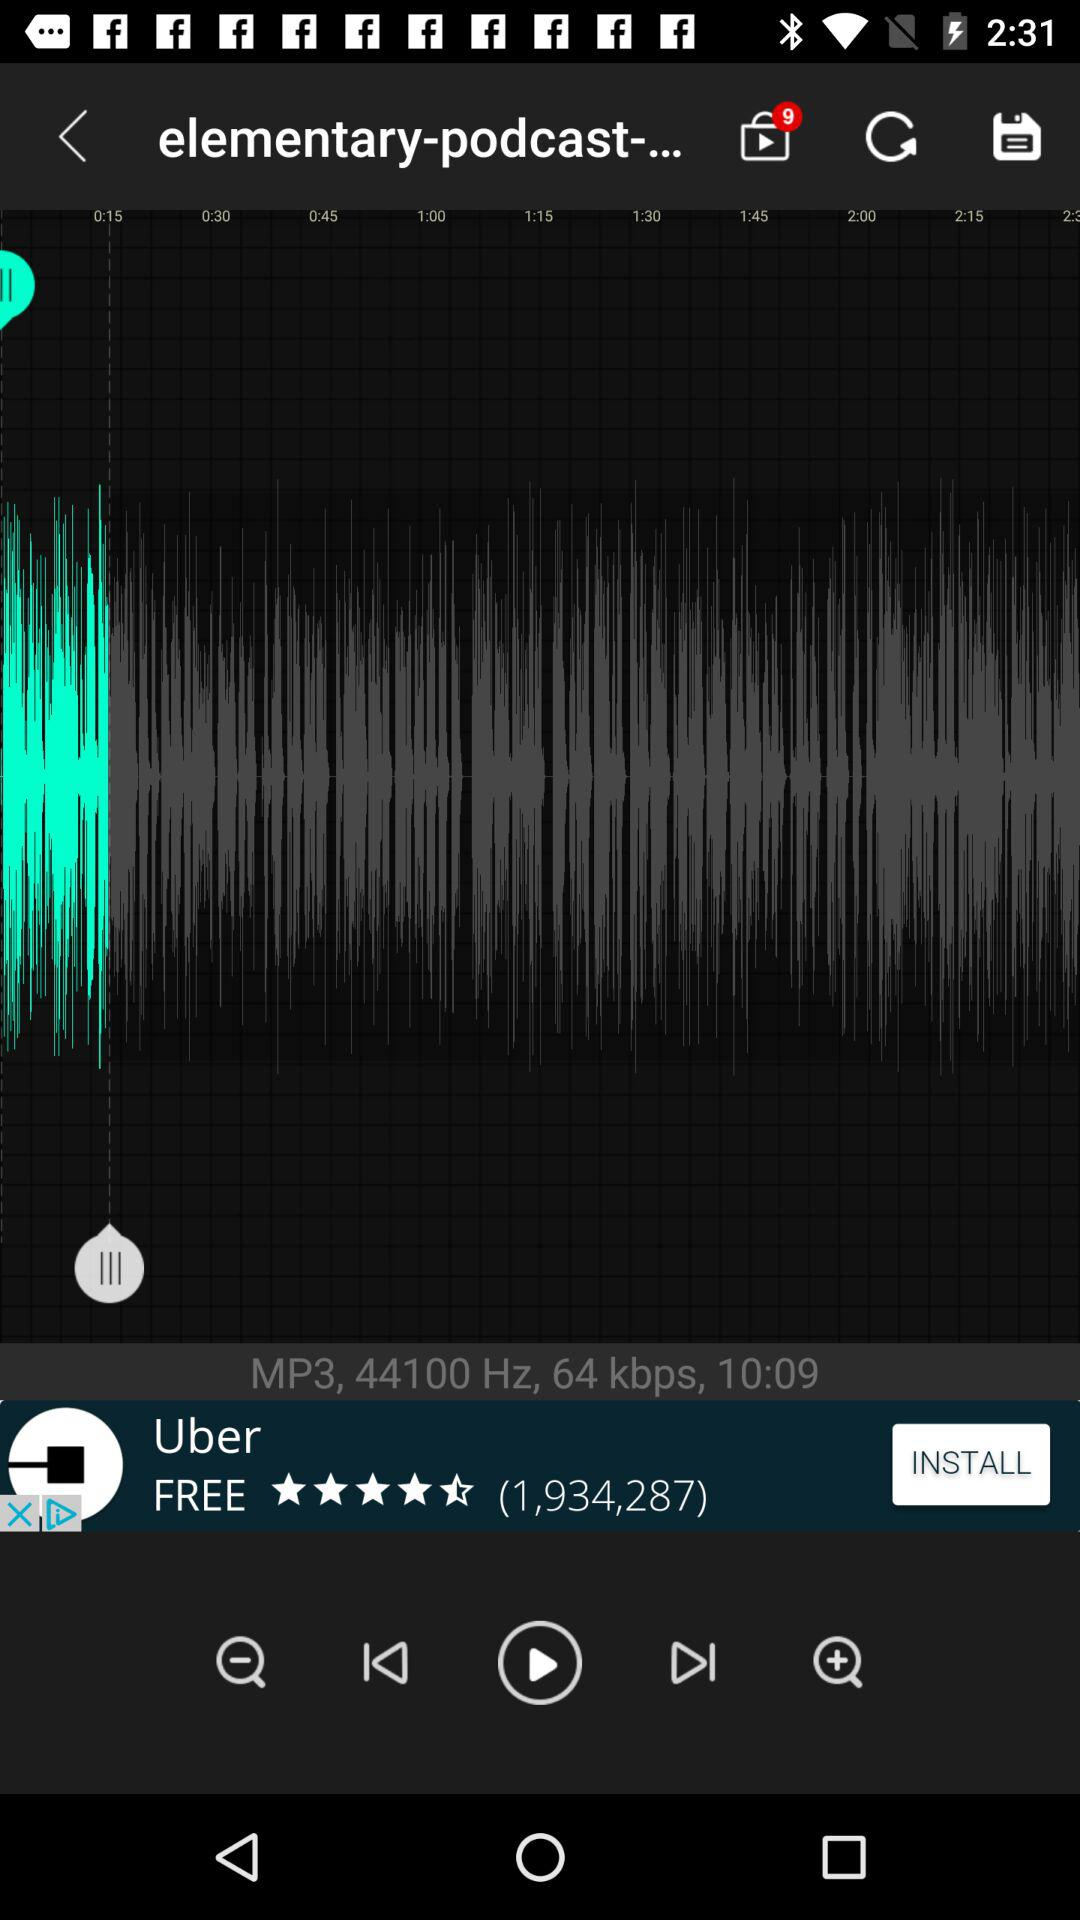What is the number of notifications? The number of notifications is 9. 